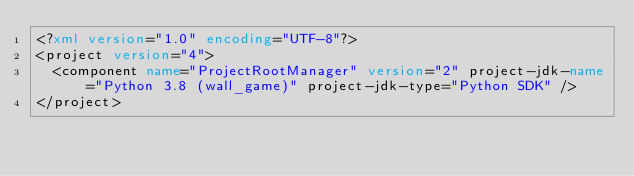Convert code to text. <code><loc_0><loc_0><loc_500><loc_500><_XML_><?xml version="1.0" encoding="UTF-8"?>
<project version="4">
  <component name="ProjectRootManager" version="2" project-jdk-name="Python 3.8 (wall_game)" project-jdk-type="Python SDK" />
</project></code> 